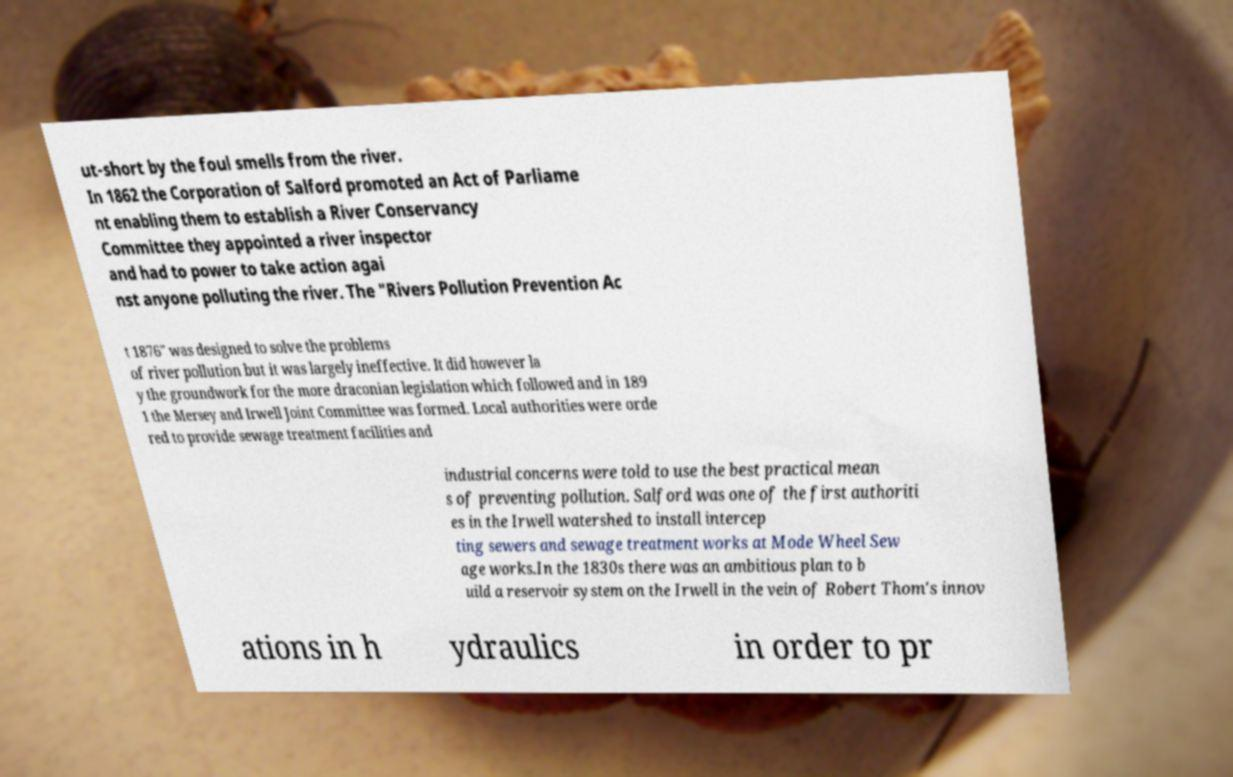Can you read and provide the text displayed in the image?This photo seems to have some interesting text. Can you extract and type it out for me? ut-short by the foul smells from the river. In 1862 the Corporation of Salford promoted an Act of Parliame nt enabling them to establish a River Conservancy Committee they appointed a river inspector and had to power to take action agai nst anyone polluting the river. The "Rivers Pollution Prevention Ac t 1876" was designed to solve the problems of river pollution but it was largely ineffective. It did however la y the groundwork for the more draconian legislation which followed and in 189 1 the Mersey and Irwell Joint Committee was formed. Local authorities were orde red to provide sewage treatment facilities and industrial concerns were told to use the best practical mean s of preventing pollution. Salford was one of the first authoriti es in the Irwell watershed to install intercep ting sewers and sewage treatment works at Mode Wheel Sew age works.In the 1830s there was an ambitious plan to b uild a reservoir system on the Irwell in the vein of Robert Thom's innov ations in h ydraulics in order to pr 